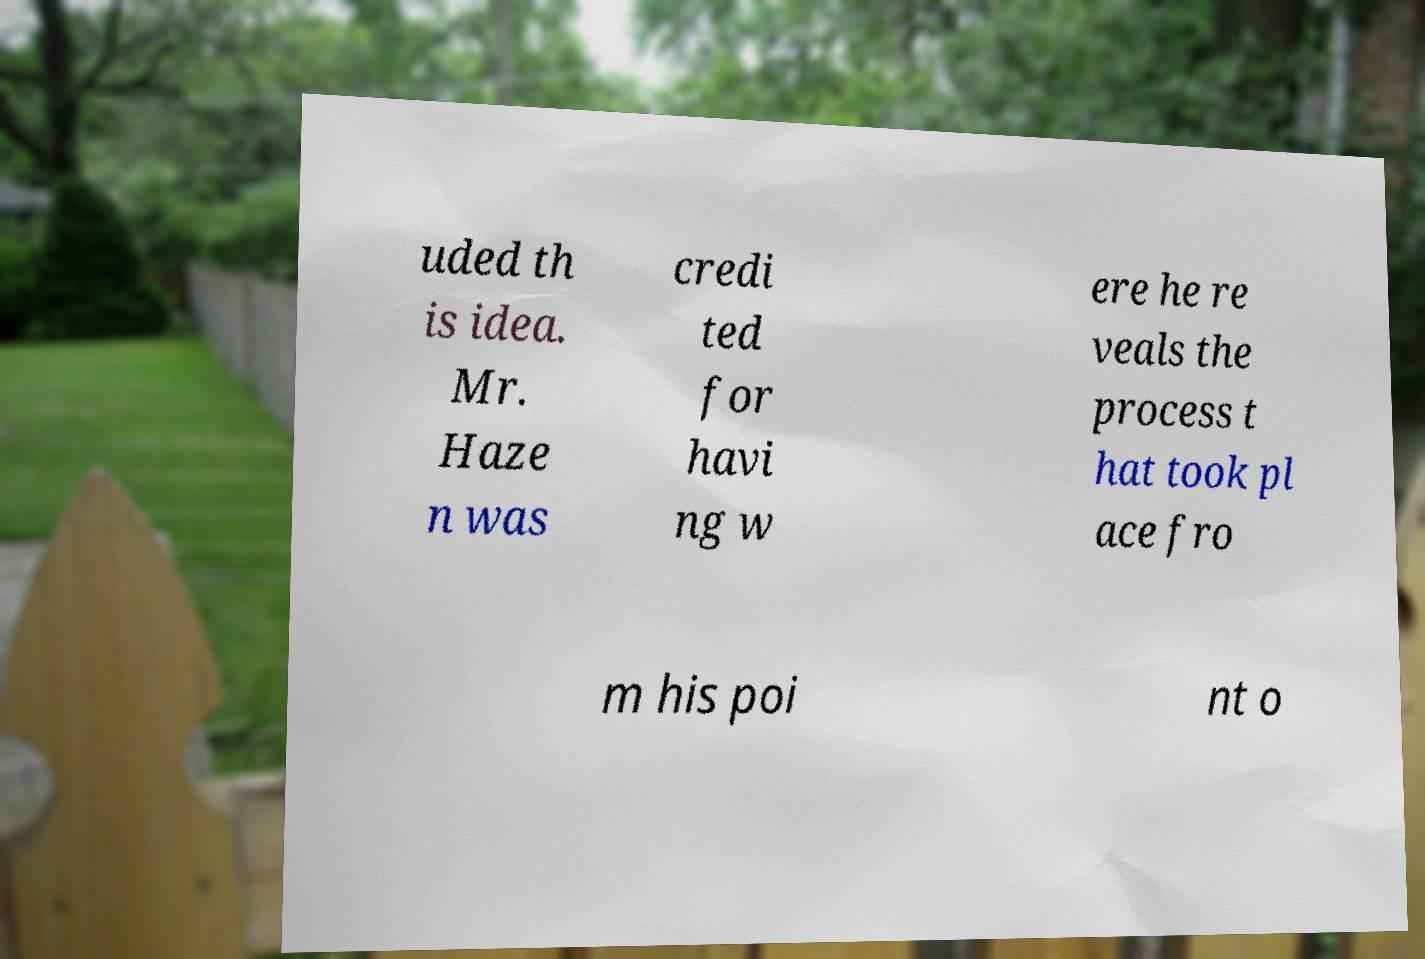Could you assist in decoding the text presented in this image and type it out clearly? uded th is idea. Mr. Haze n was credi ted for havi ng w ere he re veals the process t hat took pl ace fro m his poi nt o 